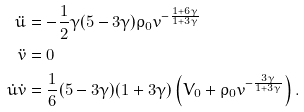<formula> <loc_0><loc_0><loc_500><loc_500>\ddot { u } & = - \frac { 1 } { 2 } \gamma ( 5 - 3 \gamma ) \rho _ { 0 } v ^ { - \frac { 1 + 6 \gamma } { 1 + 3 \gamma } } \\ \ddot { v } & = 0 \\ \dot { u } \dot { v } & = \frac { 1 } { 6 } ( 5 - 3 \gamma ) ( 1 + 3 \gamma ) \left ( V _ { 0 } + \rho _ { 0 } v ^ { - \frac { 3 \gamma } { 1 + 3 \gamma } } \right ) .</formula> 